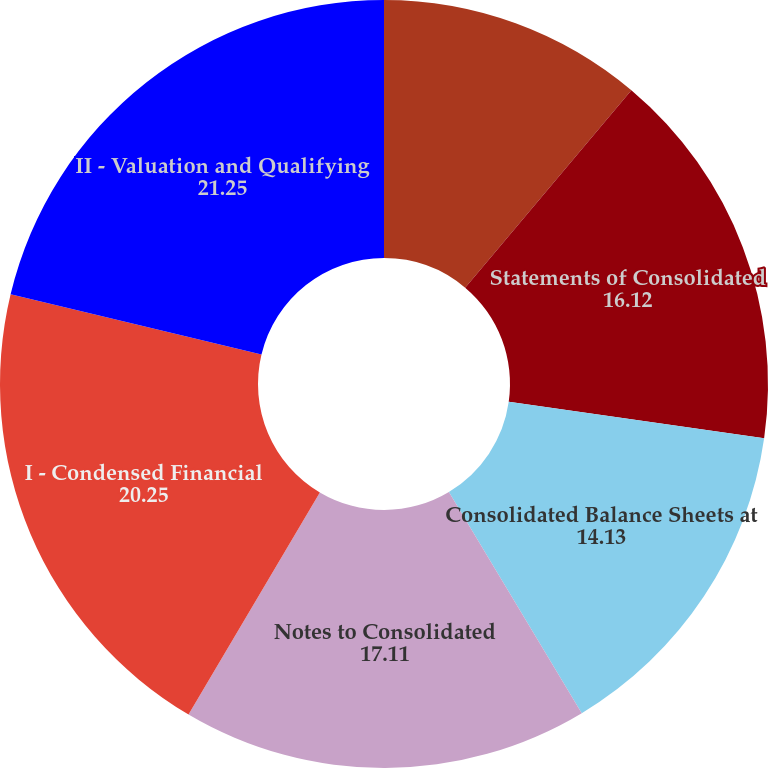<chart> <loc_0><loc_0><loc_500><loc_500><pie_chart><fcel>Report of Independent<fcel>Statements of Consolidated<fcel>Consolidated Balance Sheets at<fcel>Notes to Consolidated<fcel>I - Condensed Financial<fcel>II - Valuation and Qualifying<nl><fcel>11.14%<fcel>16.12%<fcel>14.13%<fcel>17.11%<fcel>20.25%<fcel>21.25%<nl></chart> 